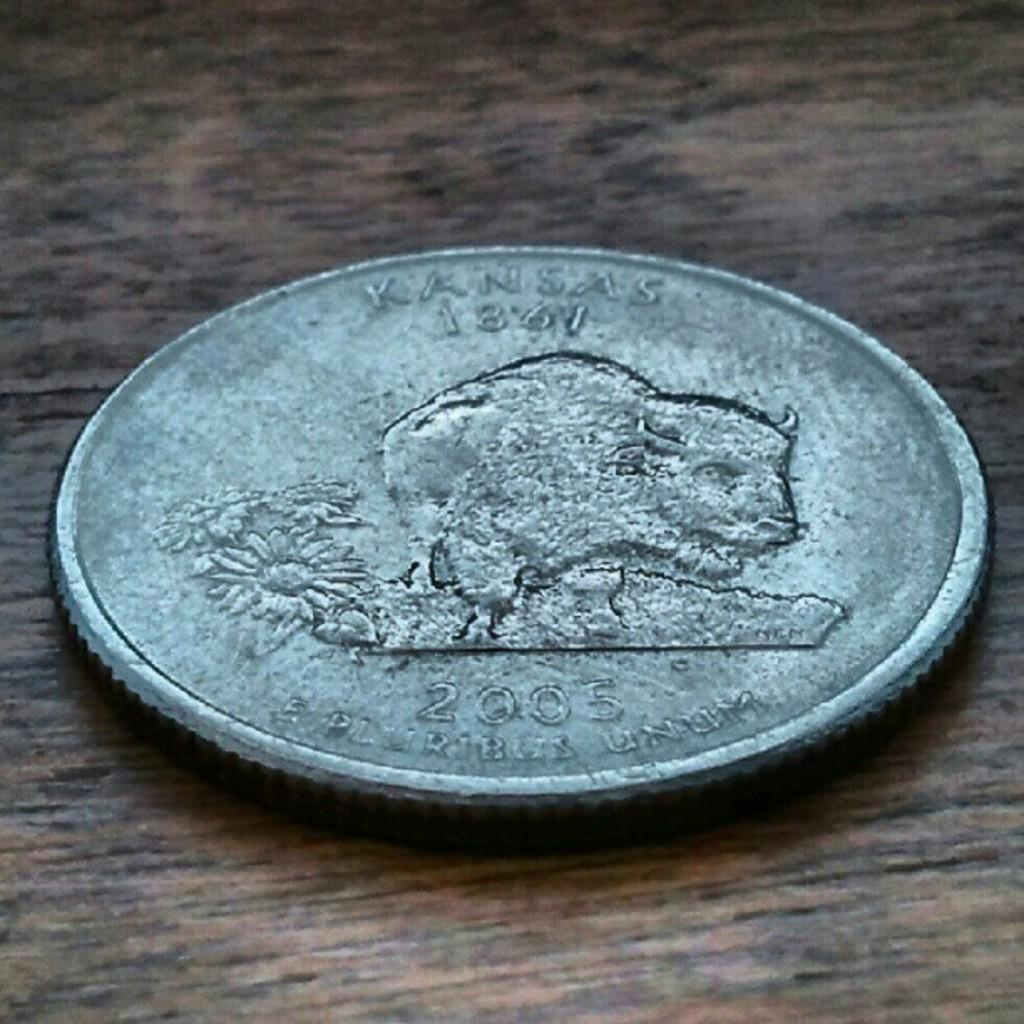<image>
Write a terse but informative summary of the picture. A coin from Kansas with a bull and some flowers on one side of the coin 